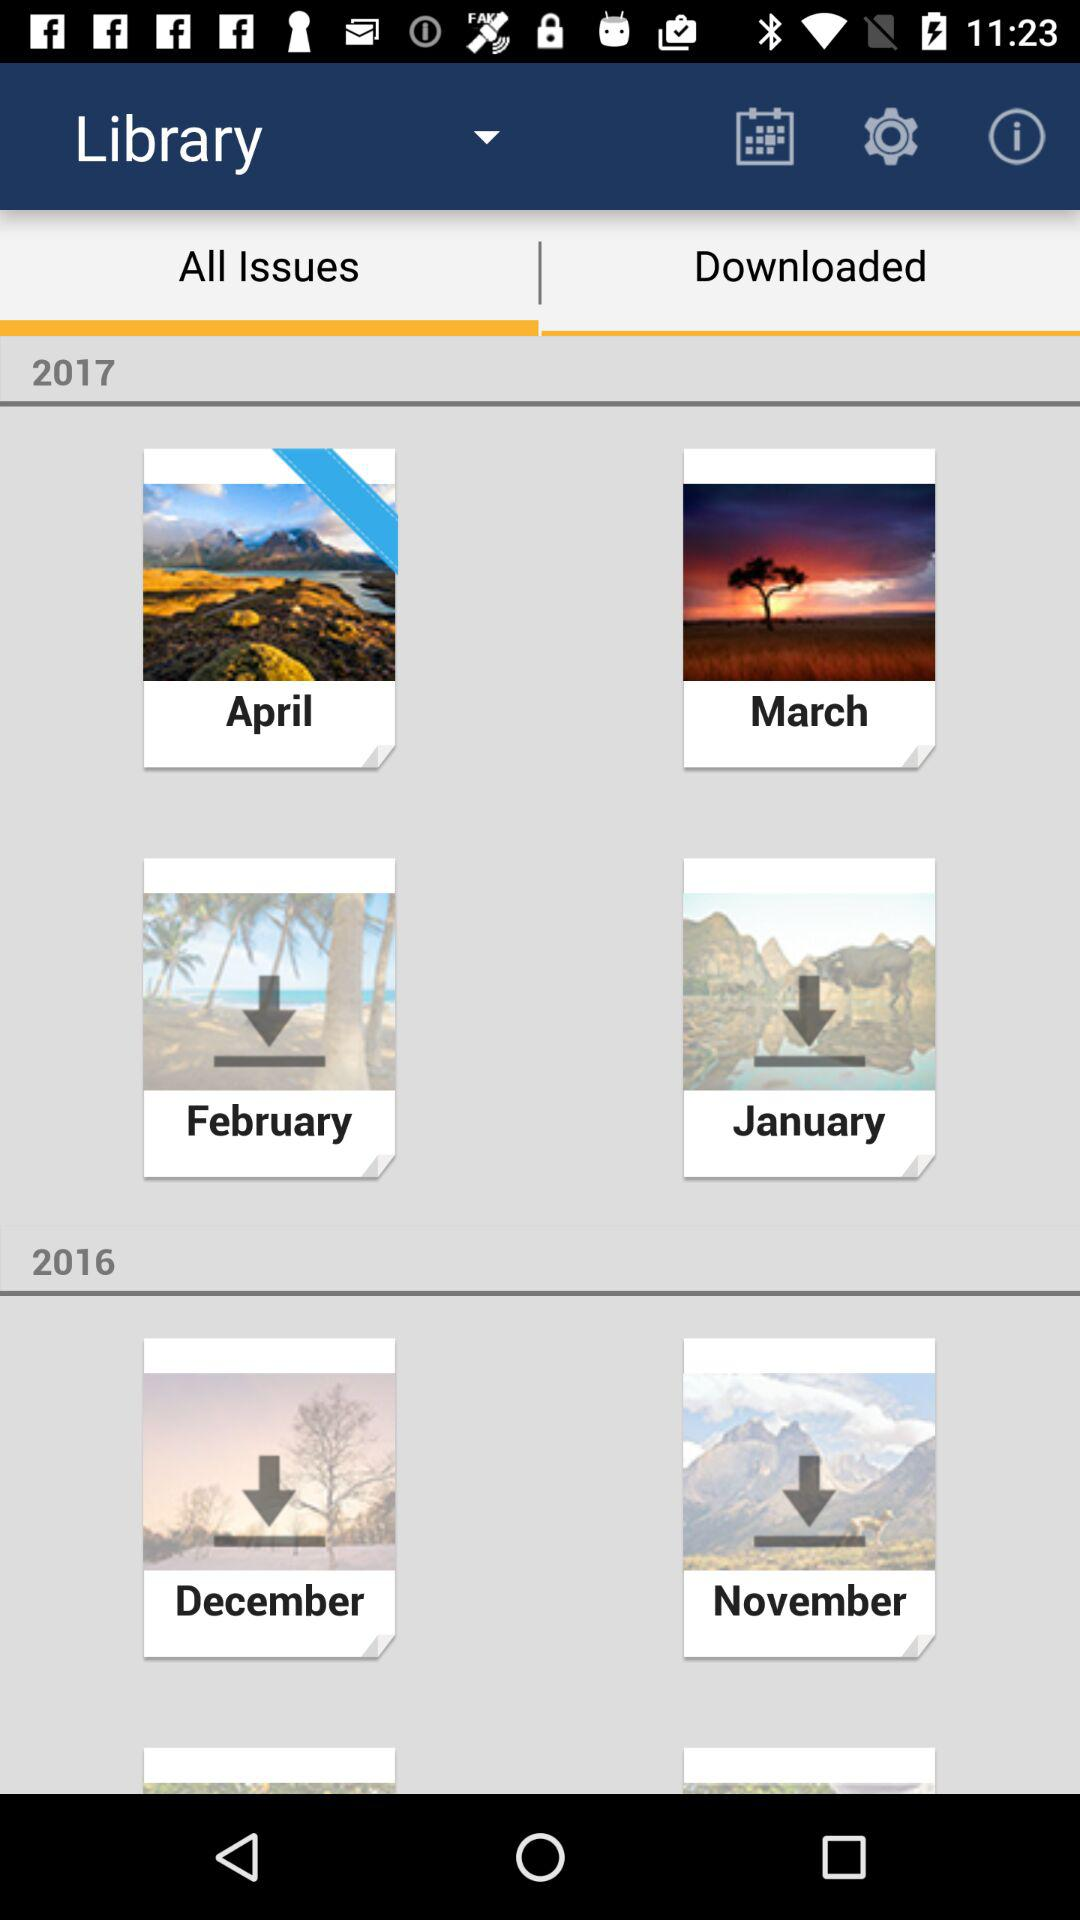Which tab is selected? The selected tab is "All Issues". 